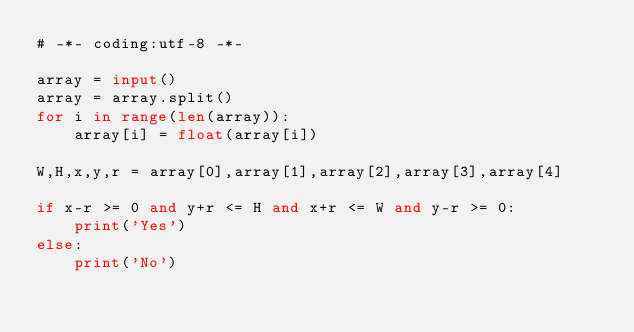Convert code to text. <code><loc_0><loc_0><loc_500><loc_500><_Python_># -*- coding:utf-8 -*-

array = input()
array = array.split()
for i in range(len(array)):
    array[i] = float(array[i])

W,H,x,y,r = array[0],array[1],array[2],array[3],array[4]

if x-r >= 0 and y+r <= H and x+r <= W and y-r >= 0:
    print('Yes')
else:
    print('No')</code> 